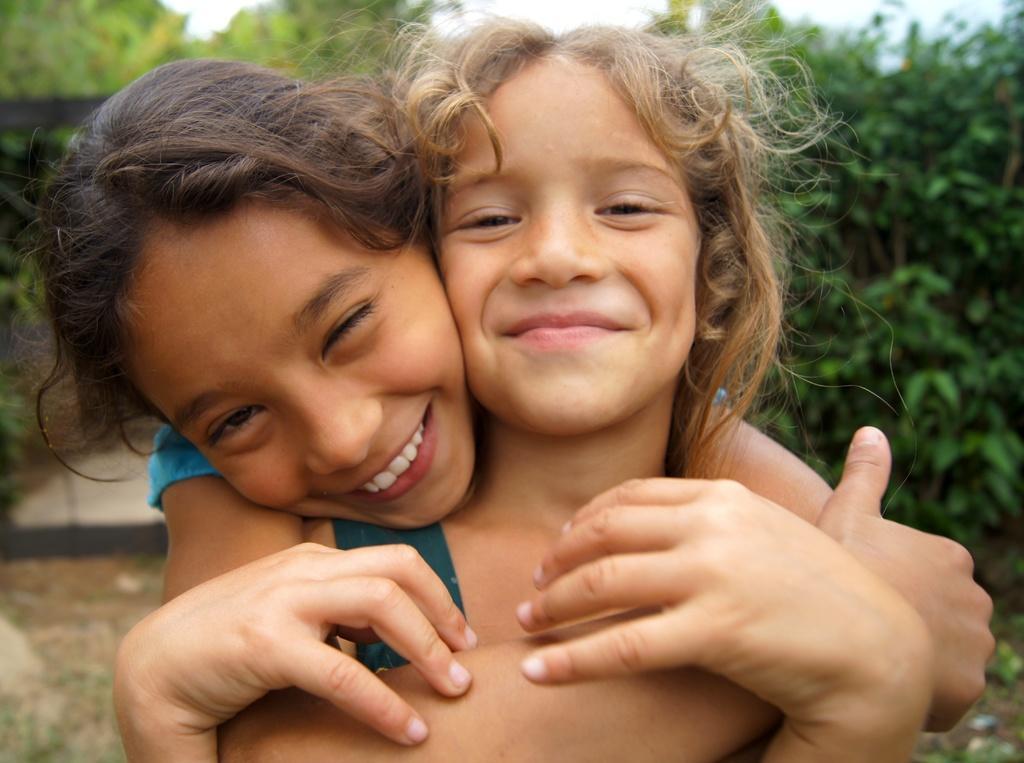Please provide a concise description of this image. In this picture we can see two girls and in the background we can see trees. 